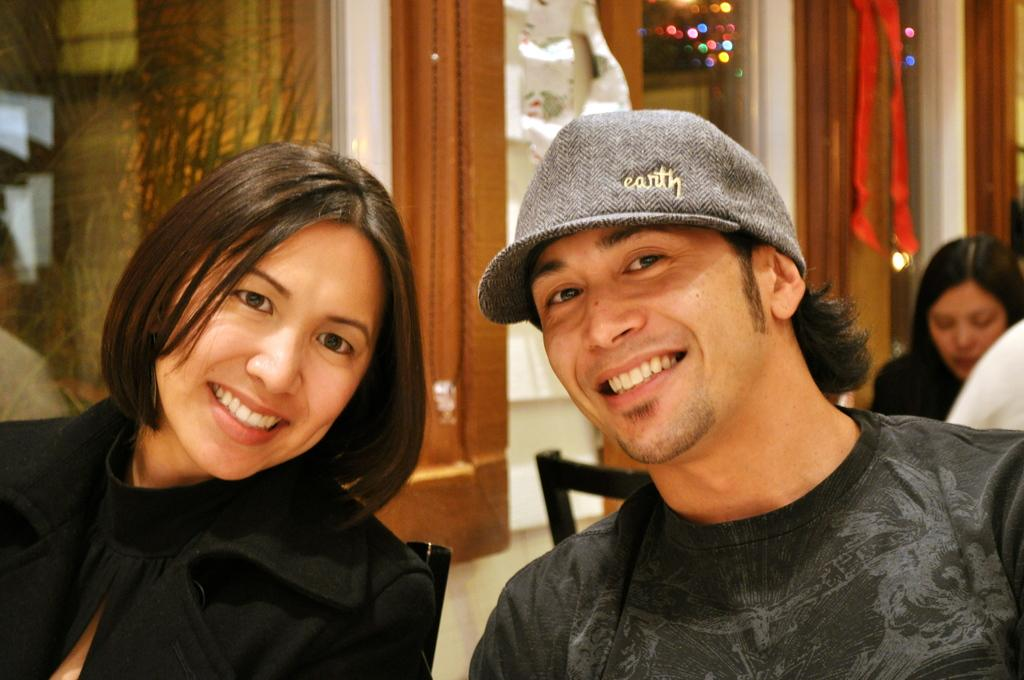What are the people in the image doing? The people in the image are sitting on chairs. What can be seen in the background of the image? There is a building with windows in the background of the image, as well as other objects. How much salt is present on the chairs in the image? There is no salt visible on the chairs in the image. What type of disease can be seen affecting the people in the image? There is no indication of any disease affecting the people in the image. 